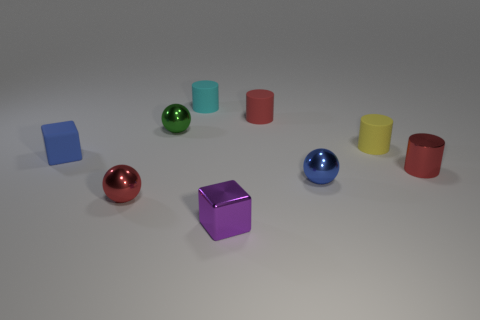Subtract all cylinders. How many objects are left? 5 Add 4 cyan cylinders. How many cyan cylinders are left? 5 Add 7 blue objects. How many blue objects exist? 9 Subtract 2 red cylinders. How many objects are left? 7 Subtract all tiny blue things. Subtract all small cubes. How many objects are left? 5 